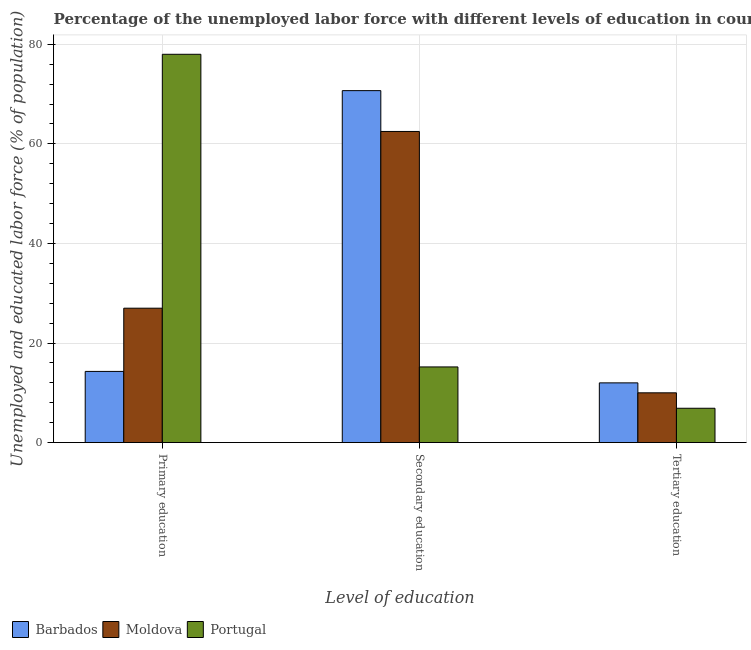How many different coloured bars are there?
Your answer should be compact. 3. Are the number of bars per tick equal to the number of legend labels?
Your answer should be very brief. Yes. Are the number of bars on each tick of the X-axis equal?
Offer a very short reply. Yes. How many bars are there on the 3rd tick from the left?
Make the answer very short. 3. What is the label of the 2nd group of bars from the left?
Offer a very short reply. Secondary education. What is the percentage of labor force who received tertiary education in Barbados?
Offer a terse response. 12. Across all countries, what is the maximum percentage of labor force who received secondary education?
Provide a succinct answer. 70.7. Across all countries, what is the minimum percentage of labor force who received tertiary education?
Your response must be concise. 6.9. In which country was the percentage of labor force who received tertiary education minimum?
Keep it short and to the point. Portugal. What is the total percentage of labor force who received secondary education in the graph?
Offer a terse response. 148.4. What is the difference between the percentage of labor force who received secondary education in Moldova and the percentage of labor force who received tertiary education in Barbados?
Offer a very short reply. 50.5. What is the average percentage of labor force who received primary education per country?
Provide a short and direct response. 39.77. What is the difference between the percentage of labor force who received tertiary education and percentage of labor force who received primary education in Barbados?
Keep it short and to the point. -2.3. In how many countries, is the percentage of labor force who received tertiary education greater than 32 %?
Your answer should be very brief. 0. What is the ratio of the percentage of labor force who received secondary education in Moldova to that in Barbados?
Offer a very short reply. 0.88. Is the percentage of labor force who received secondary education in Barbados less than that in Portugal?
Offer a terse response. No. Is the difference between the percentage of labor force who received tertiary education in Moldova and Portugal greater than the difference between the percentage of labor force who received primary education in Moldova and Portugal?
Provide a succinct answer. Yes. What is the difference between the highest and the lowest percentage of labor force who received tertiary education?
Offer a very short reply. 5.1. In how many countries, is the percentage of labor force who received tertiary education greater than the average percentage of labor force who received tertiary education taken over all countries?
Your answer should be compact. 2. What does the 2nd bar from the left in Tertiary education represents?
Your answer should be very brief. Moldova. What does the 2nd bar from the right in Primary education represents?
Ensure brevity in your answer.  Moldova. Is it the case that in every country, the sum of the percentage of labor force who received primary education and percentage of labor force who received secondary education is greater than the percentage of labor force who received tertiary education?
Your answer should be compact. Yes. How many bars are there?
Make the answer very short. 9. Are the values on the major ticks of Y-axis written in scientific E-notation?
Provide a short and direct response. No. How many legend labels are there?
Make the answer very short. 3. What is the title of the graph?
Offer a terse response. Percentage of the unemployed labor force with different levels of education in countries. Does "Israel" appear as one of the legend labels in the graph?
Provide a short and direct response. No. What is the label or title of the X-axis?
Your answer should be compact. Level of education. What is the label or title of the Y-axis?
Provide a succinct answer. Unemployed and educated labor force (% of population). What is the Unemployed and educated labor force (% of population) in Barbados in Primary education?
Keep it short and to the point. 14.3. What is the Unemployed and educated labor force (% of population) of Barbados in Secondary education?
Give a very brief answer. 70.7. What is the Unemployed and educated labor force (% of population) in Moldova in Secondary education?
Offer a terse response. 62.5. What is the Unemployed and educated labor force (% of population) of Portugal in Secondary education?
Offer a very short reply. 15.2. What is the Unemployed and educated labor force (% of population) in Moldova in Tertiary education?
Your answer should be compact. 10. What is the Unemployed and educated labor force (% of population) in Portugal in Tertiary education?
Keep it short and to the point. 6.9. Across all Level of education, what is the maximum Unemployed and educated labor force (% of population) in Barbados?
Offer a terse response. 70.7. Across all Level of education, what is the maximum Unemployed and educated labor force (% of population) in Moldova?
Provide a short and direct response. 62.5. Across all Level of education, what is the maximum Unemployed and educated labor force (% of population) of Portugal?
Your response must be concise. 78. Across all Level of education, what is the minimum Unemployed and educated labor force (% of population) in Barbados?
Ensure brevity in your answer.  12. Across all Level of education, what is the minimum Unemployed and educated labor force (% of population) in Moldova?
Your answer should be very brief. 10. Across all Level of education, what is the minimum Unemployed and educated labor force (% of population) in Portugal?
Provide a succinct answer. 6.9. What is the total Unemployed and educated labor force (% of population) of Barbados in the graph?
Make the answer very short. 97. What is the total Unemployed and educated labor force (% of population) in Moldova in the graph?
Offer a terse response. 99.5. What is the total Unemployed and educated labor force (% of population) of Portugal in the graph?
Make the answer very short. 100.1. What is the difference between the Unemployed and educated labor force (% of population) in Barbados in Primary education and that in Secondary education?
Keep it short and to the point. -56.4. What is the difference between the Unemployed and educated labor force (% of population) in Moldova in Primary education and that in Secondary education?
Keep it short and to the point. -35.5. What is the difference between the Unemployed and educated labor force (% of population) in Portugal in Primary education and that in Secondary education?
Offer a terse response. 62.8. What is the difference between the Unemployed and educated labor force (% of population) of Barbados in Primary education and that in Tertiary education?
Offer a very short reply. 2.3. What is the difference between the Unemployed and educated labor force (% of population) of Portugal in Primary education and that in Tertiary education?
Give a very brief answer. 71.1. What is the difference between the Unemployed and educated labor force (% of population) of Barbados in Secondary education and that in Tertiary education?
Ensure brevity in your answer.  58.7. What is the difference between the Unemployed and educated labor force (% of population) of Moldova in Secondary education and that in Tertiary education?
Your answer should be compact. 52.5. What is the difference between the Unemployed and educated labor force (% of population) in Portugal in Secondary education and that in Tertiary education?
Provide a succinct answer. 8.3. What is the difference between the Unemployed and educated labor force (% of population) of Barbados in Primary education and the Unemployed and educated labor force (% of population) of Moldova in Secondary education?
Your response must be concise. -48.2. What is the difference between the Unemployed and educated labor force (% of population) in Barbados in Primary education and the Unemployed and educated labor force (% of population) in Portugal in Secondary education?
Your answer should be very brief. -0.9. What is the difference between the Unemployed and educated labor force (% of population) of Barbados in Primary education and the Unemployed and educated labor force (% of population) of Moldova in Tertiary education?
Make the answer very short. 4.3. What is the difference between the Unemployed and educated labor force (% of population) of Moldova in Primary education and the Unemployed and educated labor force (% of population) of Portugal in Tertiary education?
Ensure brevity in your answer.  20.1. What is the difference between the Unemployed and educated labor force (% of population) of Barbados in Secondary education and the Unemployed and educated labor force (% of population) of Moldova in Tertiary education?
Keep it short and to the point. 60.7. What is the difference between the Unemployed and educated labor force (% of population) of Barbados in Secondary education and the Unemployed and educated labor force (% of population) of Portugal in Tertiary education?
Make the answer very short. 63.8. What is the difference between the Unemployed and educated labor force (% of population) of Moldova in Secondary education and the Unemployed and educated labor force (% of population) of Portugal in Tertiary education?
Give a very brief answer. 55.6. What is the average Unemployed and educated labor force (% of population) in Barbados per Level of education?
Give a very brief answer. 32.33. What is the average Unemployed and educated labor force (% of population) in Moldova per Level of education?
Ensure brevity in your answer.  33.17. What is the average Unemployed and educated labor force (% of population) in Portugal per Level of education?
Provide a succinct answer. 33.37. What is the difference between the Unemployed and educated labor force (% of population) in Barbados and Unemployed and educated labor force (% of population) in Portugal in Primary education?
Provide a short and direct response. -63.7. What is the difference between the Unemployed and educated labor force (% of population) in Moldova and Unemployed and educated labor force (% of population) in Portugal in Primary education?
Provide a short and direct response. -51. What is the difference between the Unemployed and educated labor force (% of population) in Barbados and Unemployed and educated labor force (% of population) in Portugal in Secondary education?
Give a very brief answer. 55.5. What is the difference between the Unemployed and educated labor force (% of population) of Moldova and Unemployed and educated labor force (% of population) of Portugal in Secondary education?
Offer a very short reply. 47.3. What is the ratio of the Unemployed and educated labor force (% of population) of Barbados in Primary education to that in Secondary education?
Your response must be concise. 0.2. What is the ratio of the Unemployed and educated labor force (% of population) in Moldova in Primary education to that in Secondary education?
Your response must be concise. 0.43. What is the ratio of the Unemployed and educated labor force (% of population) of Portugal in Primary education to that in Secondary education?
Offer a very short reply. 5.13. What is the ratio of the Unemployed and educated labor force (% of population) of Barbados in Primary education to that in Tertiary education?
Your answer should be compact. 1.19. What is the ratio of the Unemployed and educated labor force (% of population) of Moldova in Primary education to that in Tertiary education?
Offer a very short reply. 2.7. What is the ratio of the Unemployed and educated labor force (% of population) in Portugal in Primary education to that in Tertiary education?
Provide a succinct answer. 11.3. What is the ratio of the Unemployed and educated labor force (% of population) of Barbados in Secondary education to that in Tertiary education?
Give a very brief answer. 5.89. What is the ratio of the Unemployed and educated labor force (% of population) in Moldova in Secondary education to that in Tertiary education?
Provide a succinct answer. 6.25. What is the ratio of the Unemployed and educated labor force (% of population) in Portugal in Secondary education to that in Tertiary education?
Your answer should be very brief. 2.2. What is the difference between the highest and the second highest Unemployed and educated labor force (% of population) in Barbados?
Your answer should be very brief. 56.4. What is the difference between the highest and the second highest Unemployed and educated labor force (% of population) of Moldova?
Provide a succinct answer. 35.5. What is the difference between the highest and the second highest Unemployed and educated labor force (% of population) in Portugal?
Offer a very short reply. 62.8. What is the difference between the highest and the lowest Unemployed and educated labor force (% of population) of Barbados?
Provide a short and direct response. 58.7. What is the difference between the highest and the lowest Unemployed and educated labor force (% of population) of Moldova?
Your answer should be compact. 52.5. What is the difference between the highest and the lowest Unemployed and educated labor force (% of population) of Portugal?
Offer a very short reply. 71.1. 